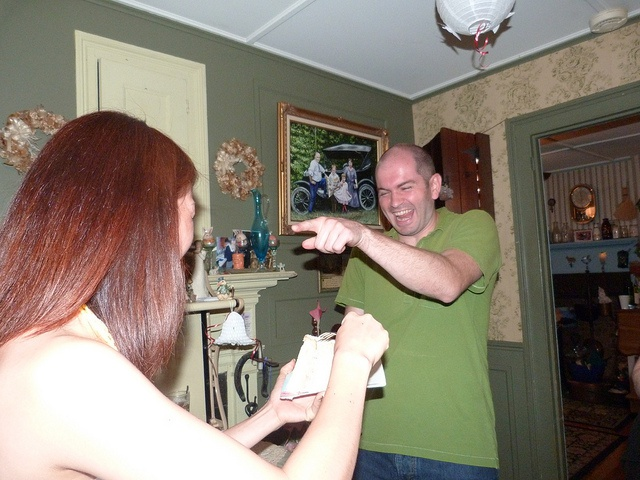Describe the objects in this image and their specific colors. I can see people in gray, white, maroon, brown, and lightpink tones, people in gray, olive, lightpink, and pink tones, cake in gray, white, darkgray, and lightpink tones, vase in gray, teal, and darkblue tones, and clock in gray, maroon, black, and tan tones in this image. 